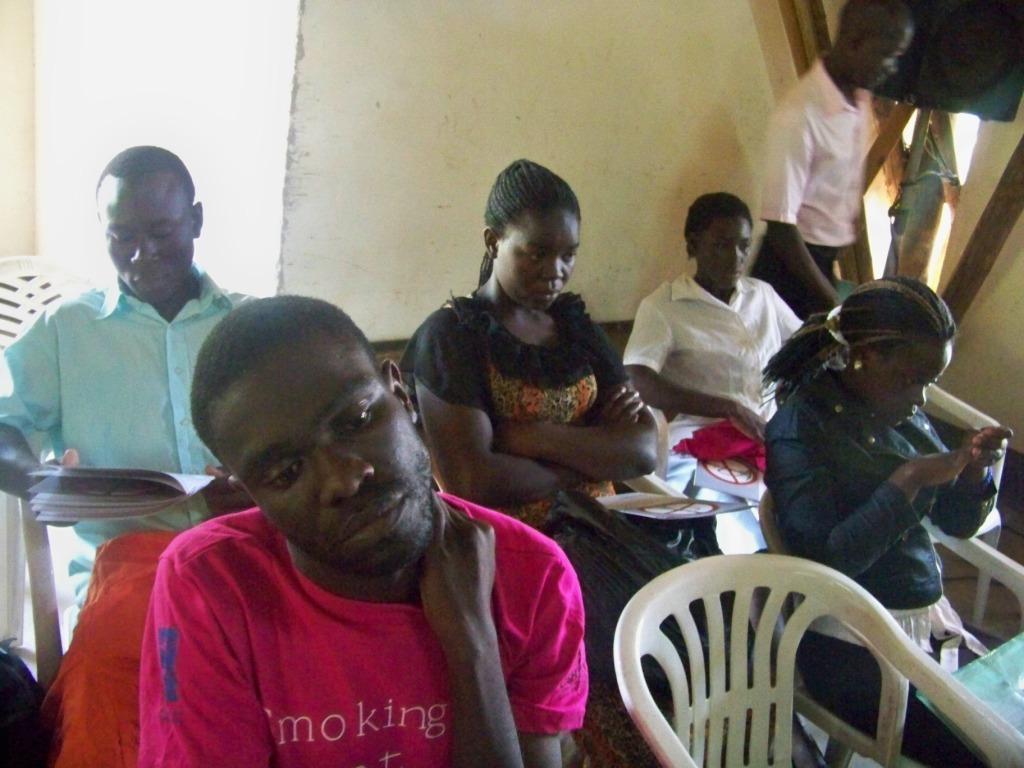Could you give a brief overview of what you see in this image? In this picture we can see some persons are sitting on the chairs. Here we can see a person who is standing on the floor. And this is the wall. 